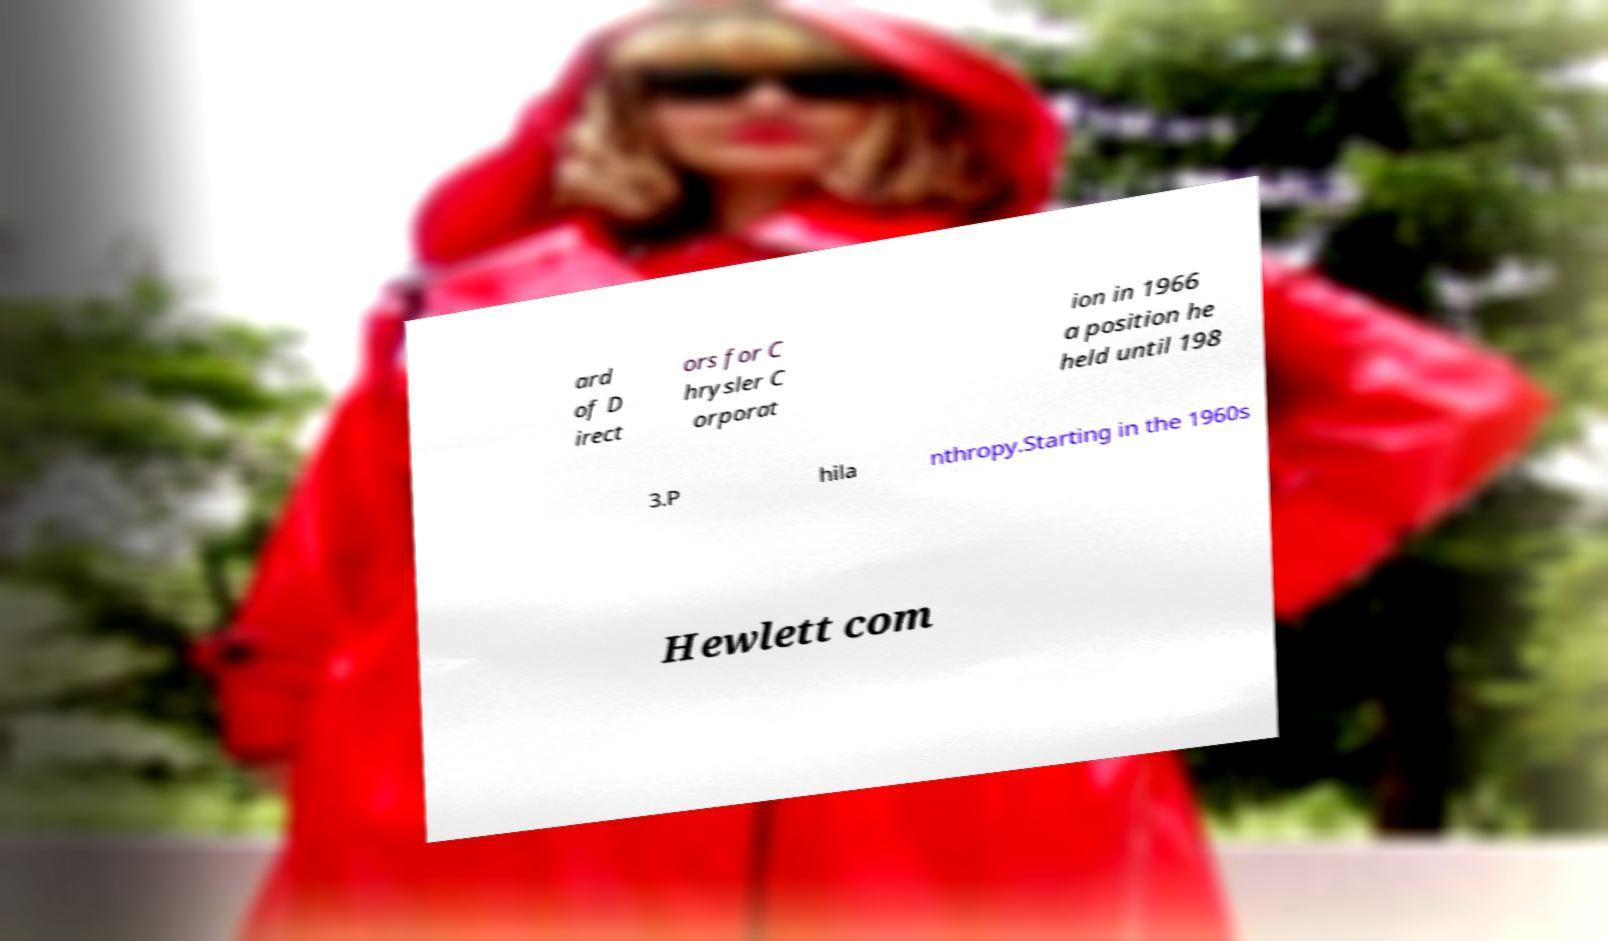Please identify and transcribe the text found in this image. ard of D irect ors for C hrysler C orporat ion in 1966 a position he held until 198 3.P hila nthropy.Starting in the 1960s Hewlett com 